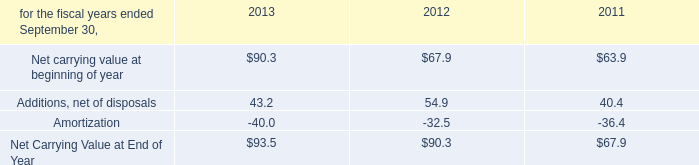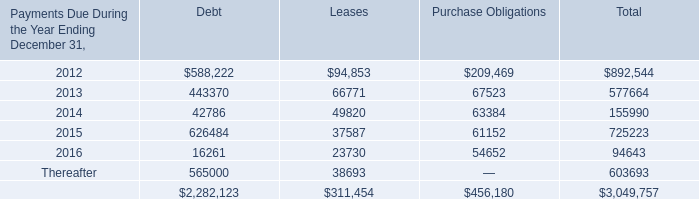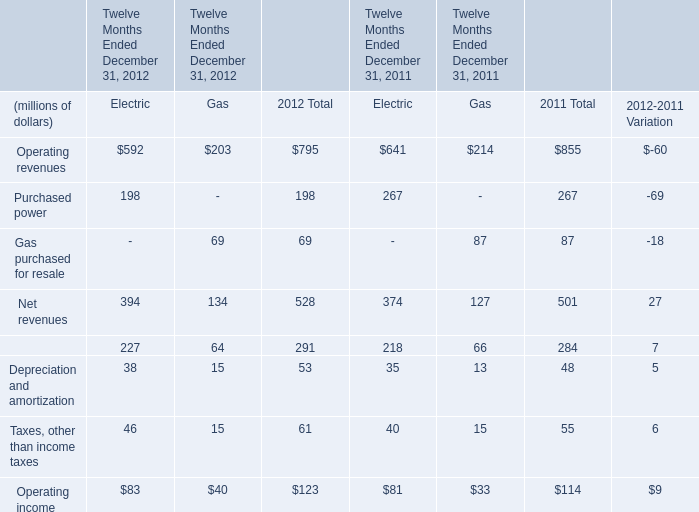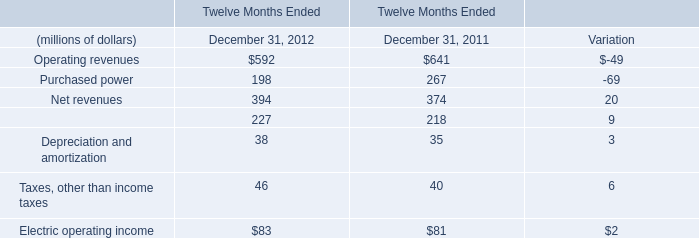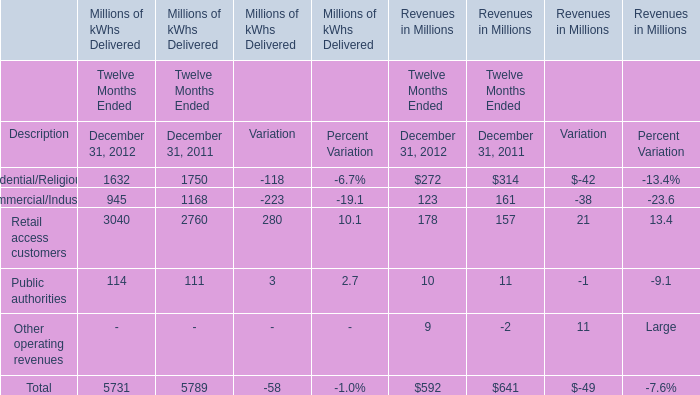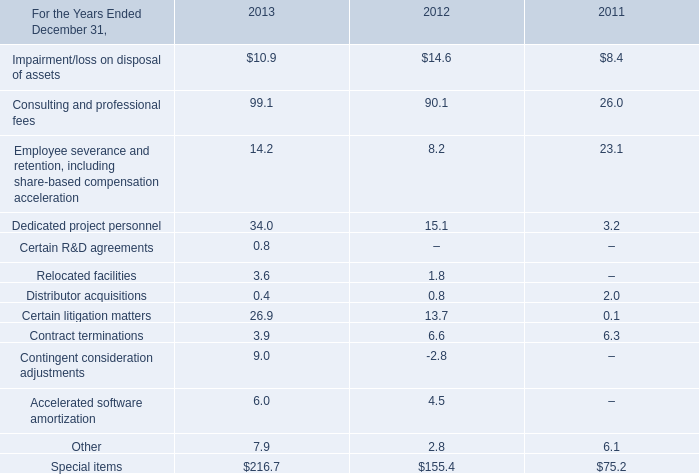What is the growing rate of Operating revenues in the year with the most December 31, 2011? 
Computations: ((641 - 592) / 641)
Answer: 0.07644. 